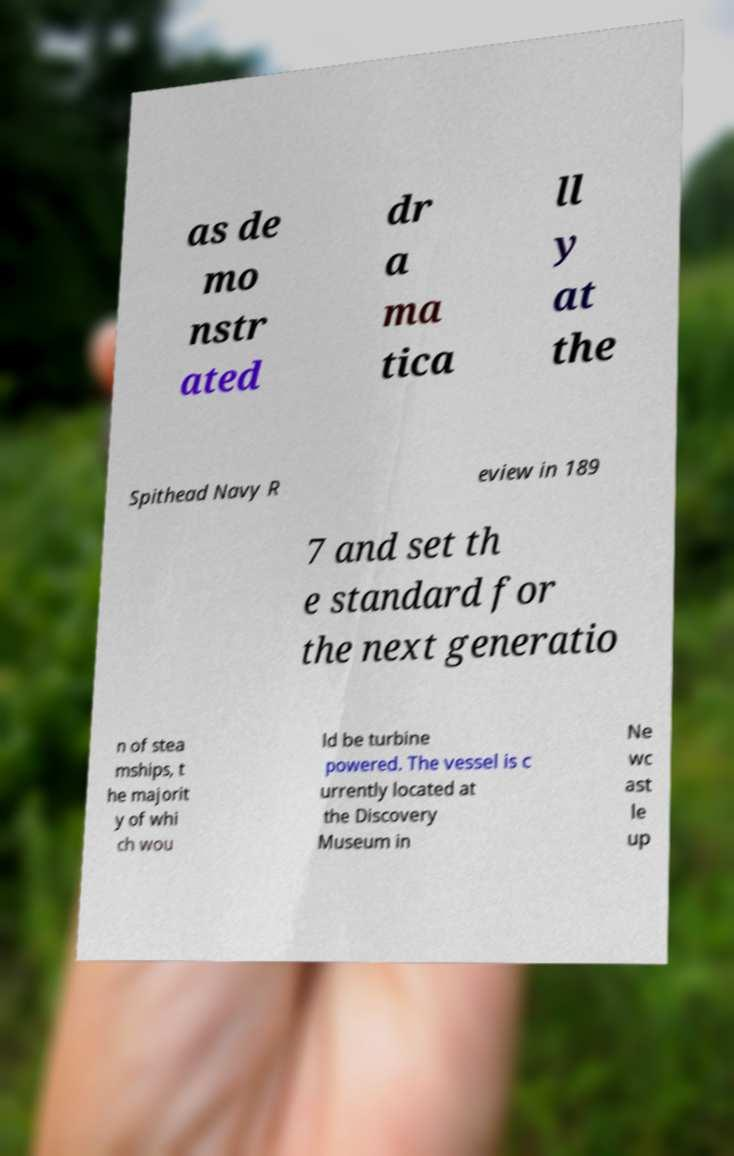Can you read and provide the text displayed in the image?This photo seems to have some interesting text. Can you extract and type it out for me? as de mo nstr ated dr a ma tica ll y at the Spithead Navy R eview in 189 7 and set th e standard for the next generatio n of stea mships, t he majorit y of whi ch wou ld be turbine powered. The vessel is c urrently located at the Discovery Museum in Ne wc ast le up 